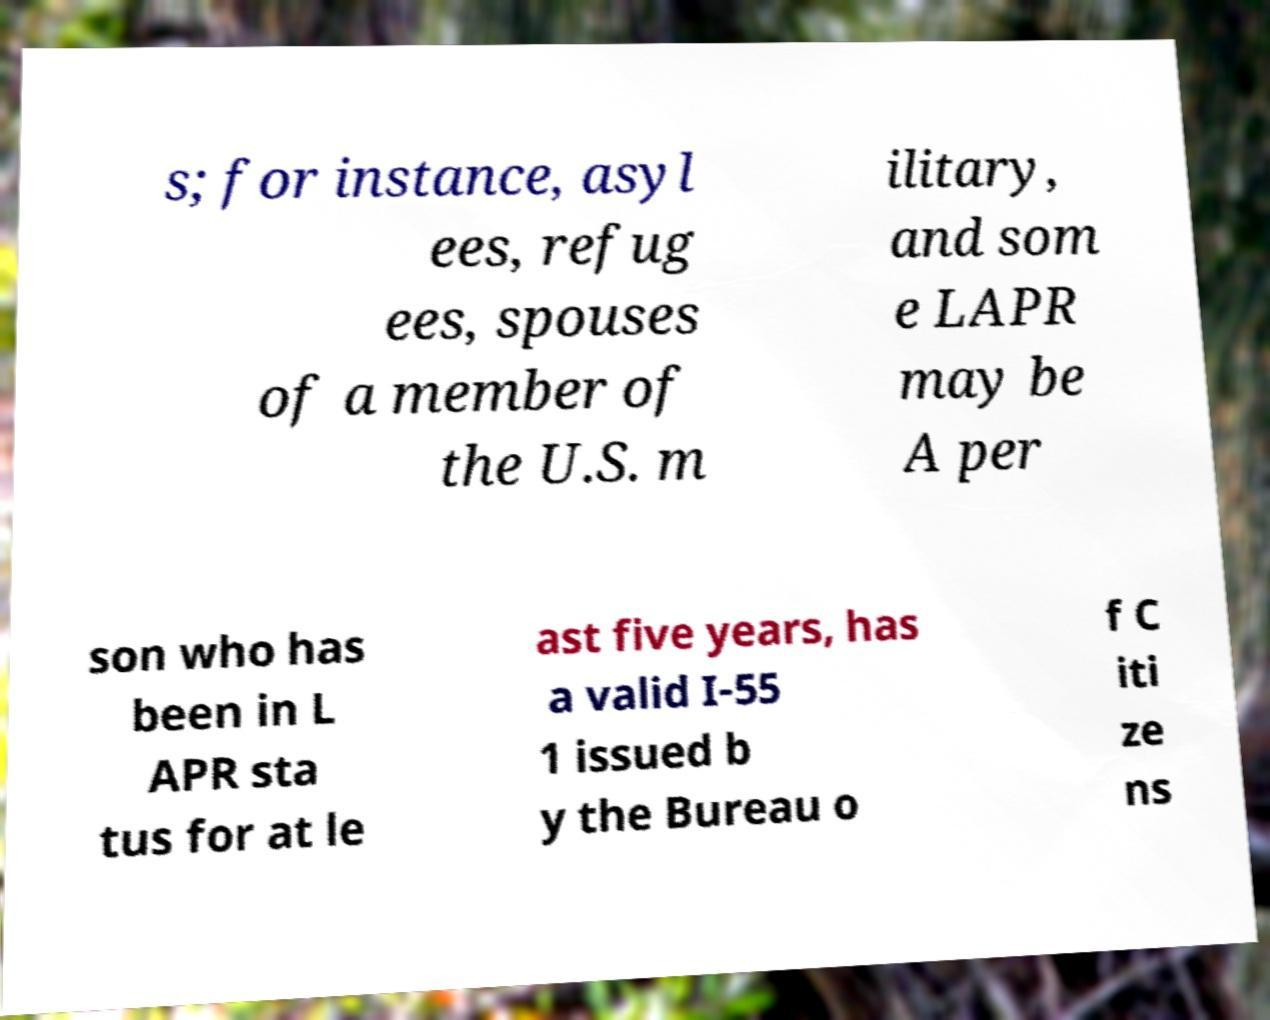Please read and relay the text visible in this image. What does it say? s; for instance, asyl ees, refug ees, spouses of a member of the U.S. m ilitary, and som e LAPR may be A per son who has been in L APR sta tus for at le ast five years, has a valid I-55 1 issued b y the Bureau o f C iti ze ns 